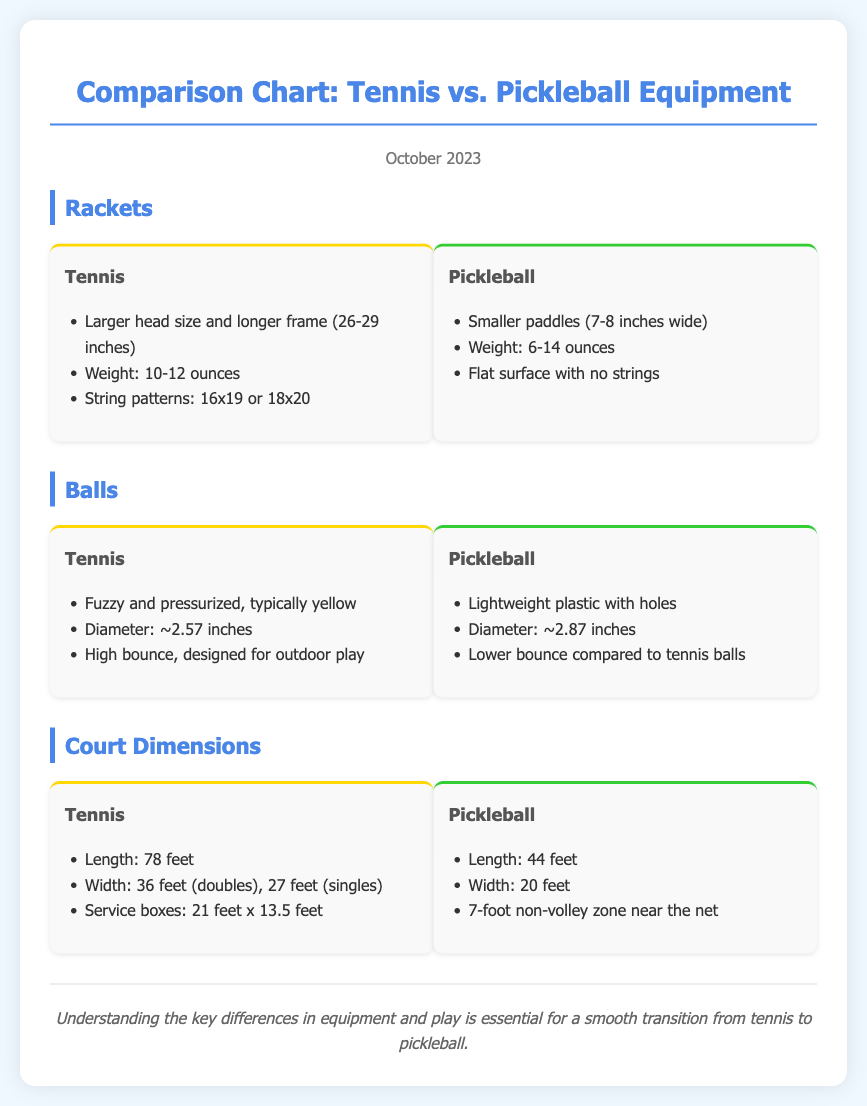what is the head size of tennis rackets? The document states that tennis rackets have a larger head size and longer frame.
Answer: larger head size what is the weight range for pickleball paddles? The document mentions that pickleball paddles weigh between 6 to 14 ounces.
Answer: 6-14 ounces what is the diameter of a tennis ball? The diameter of a tennis ball is approximately 2.57 inches according to the document.
Answer: ~2.57 inches how wide is a pickleball court? The document indicates that a pickleball court is 20 feet wide.
Answer: 20 feet what should tennis players note when transitioning to pickleball? The document highlights that understanding key differences in equipment and play is essential for a smooth transition.
Answer: key differences in equipment and play what is the length of a tennis court? According to the document, the length of a tennis court is 78 feet.
Answer: 78 feet what type of surface do tennis rackets have? The document states that tennis rackets have string patterns.
Answer: string patterns what is the non-volley zone size in pickleball? The document mentions a 7-foot non-volley zone near the net in pickleball.
Answer: 7-foot non-volley zone what color are typical tennis balls? The document describes tennis balls as typically yellow.
Answer: yellow 